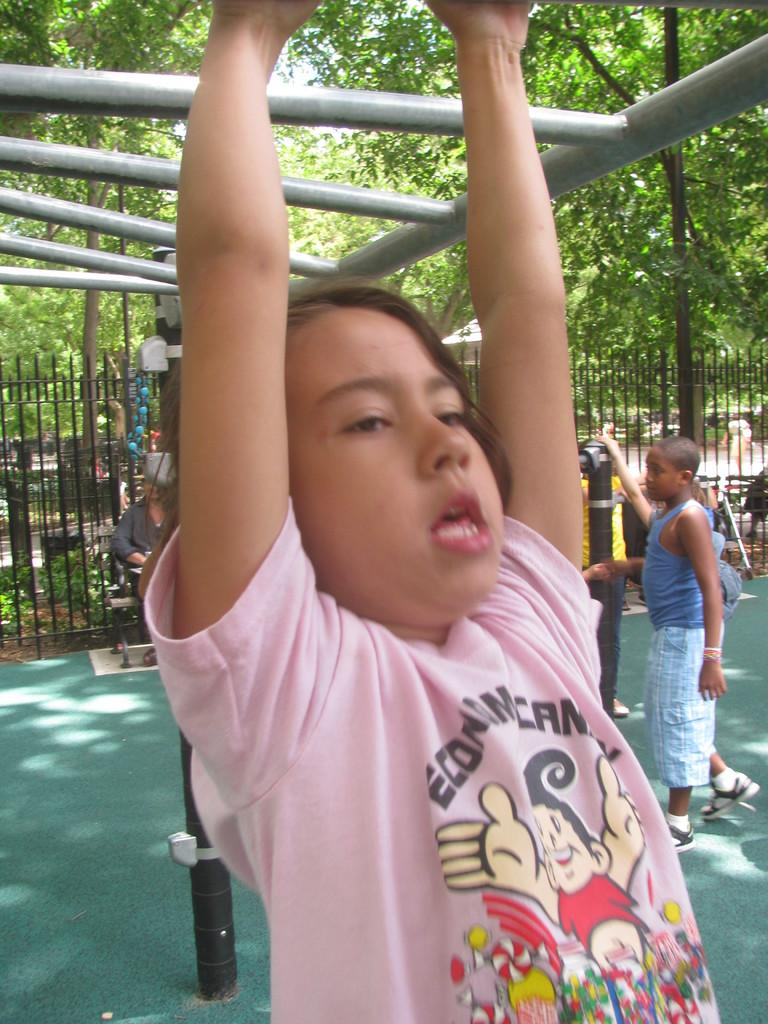Who is the main subject in the image? There is a girl in the image. What is the girl doing in the image? The girl is sitting on a bench in the image. What is the girl sitting on? There is a bench in the image. What can be seen in the background of the image? There is a fence, people, and trees in the background of the image. How many waves can be seen crashing on the shore in the image? There are no waves present in the image; it features a girl sitting on a bench with a fence, people, and trees in the background. 